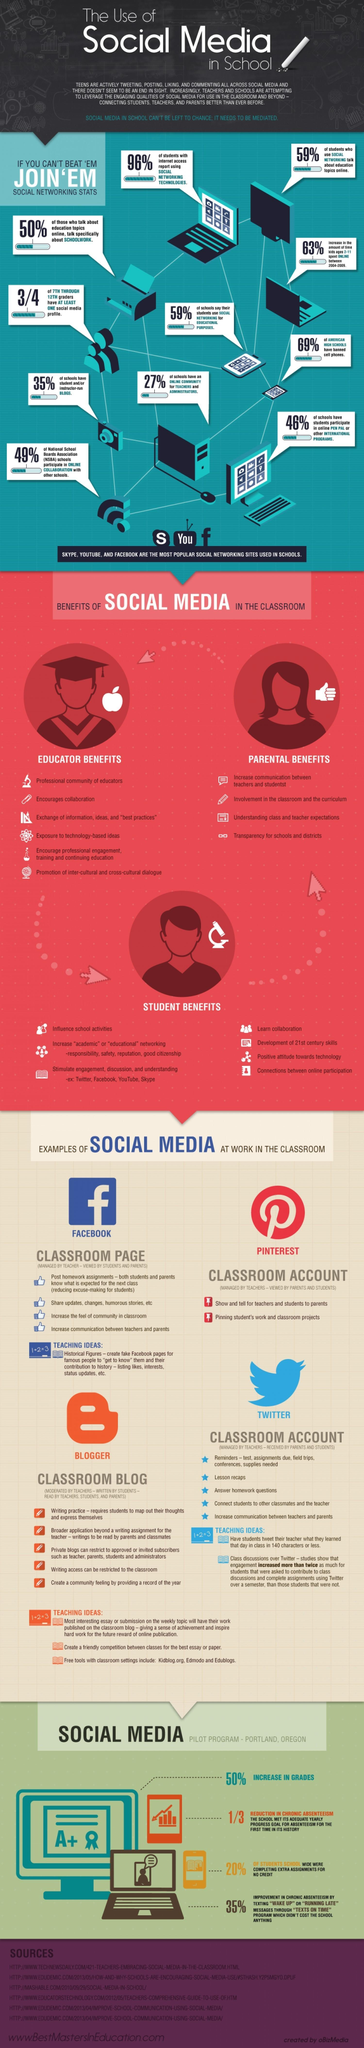Specify some key components in this picture. Four points are under the heading "Parental benefits. There are six points under the heading "Educator Benefits. According to a recent survey, 31% of American high schools have not banned the use of cell phones among students. A significant percentage of schools, approximately 73%, lack an online community for teachers and administrators. 